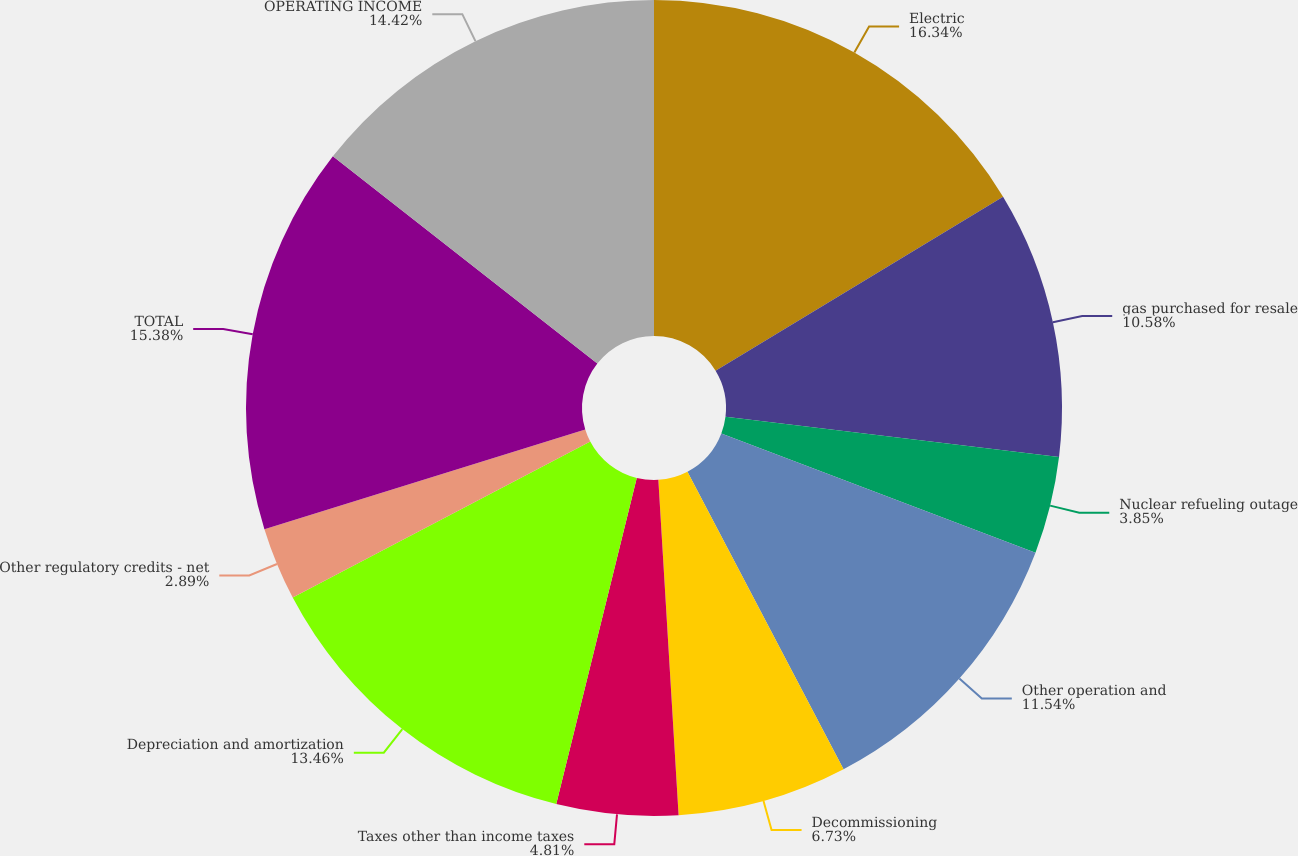Convert chart to OTSL. <chart><loc_0><loc_0><loc_500><loc_500><pie_chart><fcel>Electric<fcel>gas purchased for resale<fcel>Nuclear refueling outage<fcel>Other operation and<fcel>Decommissioning<fcel>Taxes other than income taxes<fcel>Depreciation and amortization<fcel>Other regulatory credits - net<fcel>TOTAL<fcel>OPERATING INCOME<nl><fcel>16.34%<fcel>10.58%<fcel>3.85%<fcel>11.54%<fcel>6.73%<fcel>4.81%<fcel>13.46%<fcel>2.89%<fcel>15.38%<fcel>14.42%<nl></chart> 